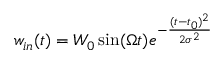Convert formula to latex. <formula><loc_0><loc_0><loc_500><loc_500>w _ { i n } ( t ) = W _ { 0 } \sin ( \Omega t ) e ^ { - \frac { ( t - t _ { 0 } ) ^ { 2 } } { 2 \sigma ^ { 2 } } }</formula> 